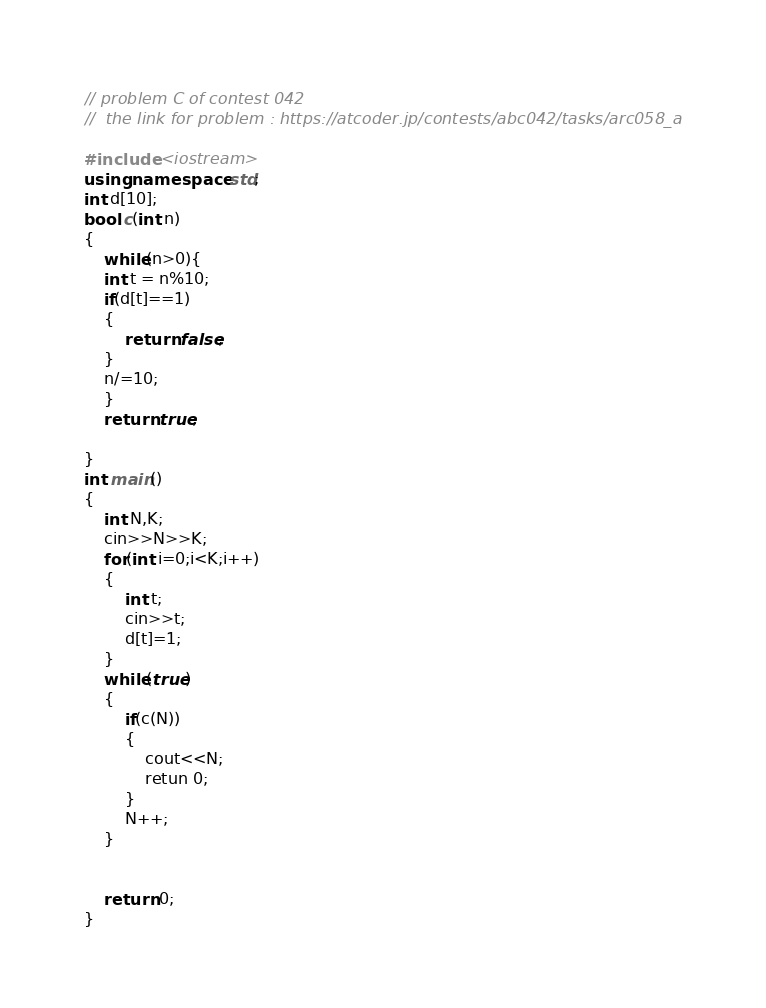Convert code to text. <code><loc_0><loc_0><loc_500><loc_500><_C++_>// problem C of contest 042
//  the link for problem : https://atcoder.jp/contests/abc042/tasks/arc058_a

#include <iostream>
using namespace std;
int d[10];
bool c(int n)
{
    while(n>0){
    int t = n%10;
    if(d[t]==1)
    {
        return false;
    }
    n/=10;
    }
    return true;

}
int main()
{
    int N,K;
    cin>>N>>K;
    for(int i=0;i<K;i++)
    {
        int t;
        cin>>t;
        d[t]=1;
    }
    while(true)
    {
        if(c(N))
        {
            cout<<N;
            retun 0;
        }
        N++;
    }


    return 0;
}</code> 